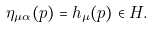<formula> <loc_0><loc_0><loc_500><loc_500>\eta _ { \mu \alpha } ( p ) = h _ { \mu } ( p ) \in H .</formula> 